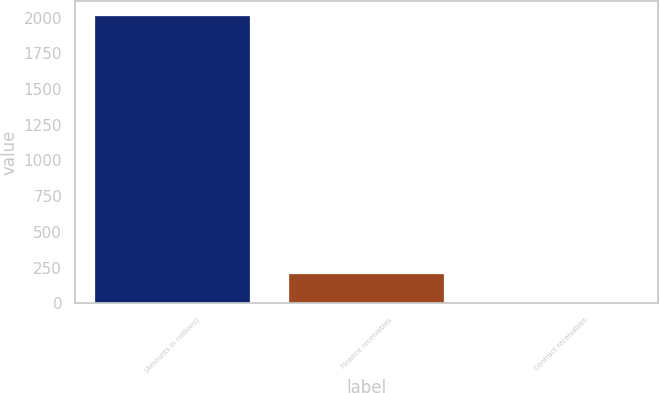<chart> <loc_0><loc_0><loc_500><loc_500><bar_chart><fcel>(Amounts in millions)<fcel>Finance receivables<fcel>Contract receivables<nl><fcel>2013<fcel>202.2<fcel>1<nl></chart> 